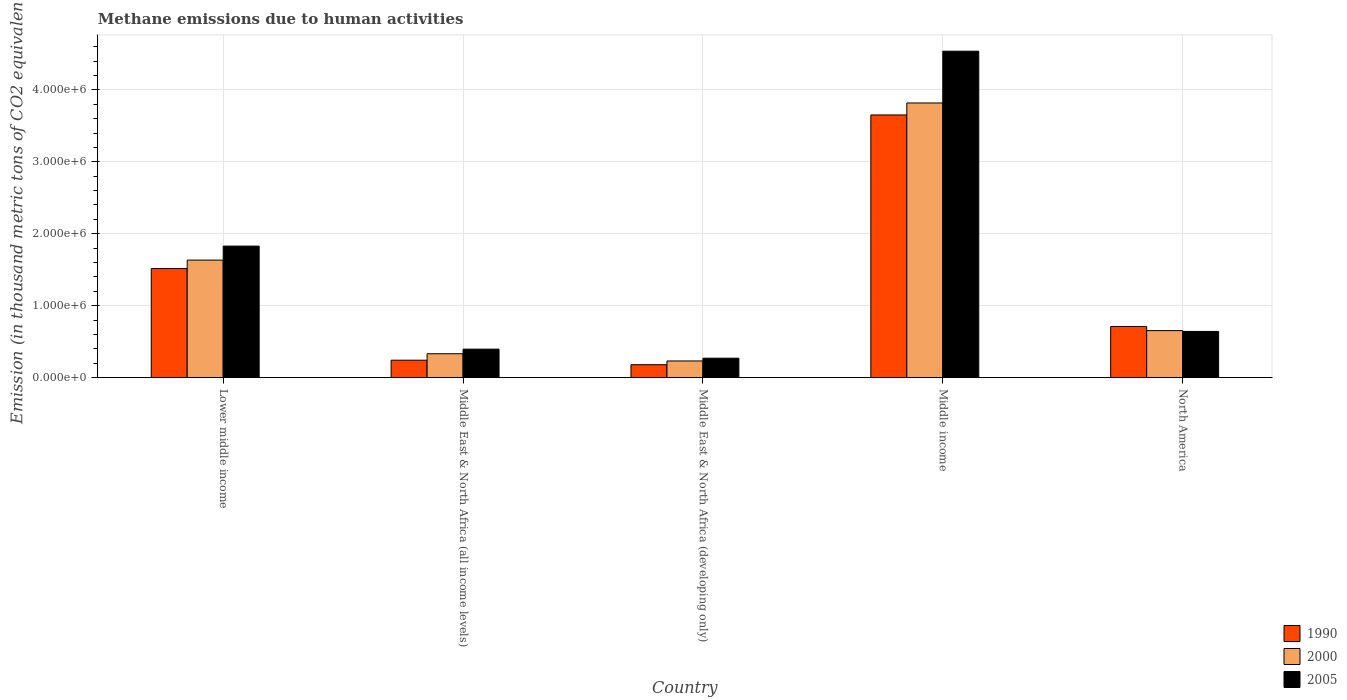How many bars are there on the 2nd tick from the left?
Give a very brief answer. 3. How many bars are there on the 3rd tick from the right?
Offer a very short reply. 3. What is the label of the 2nd group of bars from the left?
Your response must be concise. Middle East & North Africa (all income levels). In how many cases, is the number of bars for a given country not equal to the number of legend labels?
Your answer should be very brief. 0. What is the amount of methane emitted in 2005 in Middle income?
Make the answer very short. 4.54e+06. Across all countries, what is the maximum amount of methane emitted in 1990?
Your response must be concise. 3.65e+06. Across all countries, what is the minimum amount of methane emitted in 1990?
Provide a succinct answer. 1.80e+05. In which country was the amount of methane emitted in 2005 minimum?
Give a very brief answer. Middle East & North Africa (developing only). What is the total amount of methane emitted in 2000 in the graph?
Provide a succinct answer. 6.67e+06. What is the difference between the amount of methane emitted in 2005 in Middle East & North Africa (developing only) and that in Middle income?
Give a very brief answer. -4.27e+06. What is the difference between the amount of methane emitted in 1990 in North America and the amount of methane emitted in 2000 in Middle income?
Your answer should be compact. -3.11e+06. What is the average amount of methane emitted in 2005 per country?
Give a very brief answer. 1.54e+06. What is the difference between the amount of methane emitted of/in 1990 and amount of methane emitted of/in 2000 in Lower middle income?
Make the answer very short. -1.18e+05. In how many countries, is the amount of methane emitted in 2005 greater than 4400000 thousand metric tons?
Provide a short and direct response. 1. What is the ratio of the amount of methane emitted in 1990 in Middle East & North Africa (all income levels) to that in Middle income?
Your response must be concise. 0.07. Is the amount of methane emitted in 2000 in Middle East & North Africa (all income levels) less than that in Middle East & North Africa (developing only)?
Keep it short and to the point. No. What is the difference between the highest and the second highest amount of methane emitted in 1990?
Offer a very short reply. 2.94e+06. What is the difference between the highest and the lowest amount of methane emitted in 2005?
Your answer should be compact. 4.27e+06. In how many countries, is the amount of methane emitted in 2005 greater than the average amount of methane emitted in 2005 taken over all countries?
Provide a short and direct response. 2. Is it the case that in every country, the sum of the amount of methane emitted in 1990 and amount of methane emitted in 2000 is greater than the amount of methane emitted in 2005?
Make the answer very short. Yes. Are all the bars in the graph horizontal?
Offer a very short reply. No. Are the values on the major ticks of Y-axis written in scientific E-notation?
Your answer should be compact. Yes. Where does the legend appear in the graph?
Your answer should be compact. Bottom right. What is the title of the graph?
Ensure brevity in your answer.  Methane emissions due to human activities. What is the label or title of the Y-axis?
Your answer should be very brief. Emission (in thousand metric tons of CO2 equivalent). What is the Emission (in thousand metric tons of CO2 equivalent) in 1990 in Lower middle income?
Ensure brevity in your answer.  1.52e+06. What is the Emission (in thousand metric tons of CO2 equivalent) in 2000 in Lower middle income?
Your response must be concise. 1.63e+06. What is the Emission (in thousand metric tons of CO2 equivalent) in 2005 in Lower middle income?
Ensure brevity in your answer.  1.83e+06. What is the Emission (in thousand metric tons of CO2 equivalent) of 1990 in Middle East & North Africa (all income levels)?
Offer a very short reply. 2.43e+05. What is the Emission (in thousand metric tons of CO2 equivalent) in 2000 in Middle East & North Africa (all income levels)?
Offer a terse response. 3.33e+05. What is the Emission (in thousand metric tons of CO2 equivalent) of 2005 in Middle East & North Africa (all income levels)?
Offer a very short reply. 3.96e+05. What is the Emission (in thousand metric tons of CO2 equivalent) in 1990 in Middle East & North Africa (developing only)?
Offer a very short reply. 1.80e+05. What is the Emission (in thousand metric tons of CO2 equivalent) of 2000 in Middle East & North Africa (developing only)?
Your answer should be compact. 2.32e+05. What is the Emission (in thousand metric tons of CO2 equivalent) of 2005 in Middle East & North Africa (developing only)?
Offer a terse response. 2.71e+05. What is the Emission (in thousand metric tons of CO2 equivalent) in 1990 in Middle income?
Keep it short and to the point. 3.65e+06. What is the Emission (in thousand metric tons of CO2 equivalent) in 2000 in Middle income?
Give a very brief answer. 3.82e+06. What is the Emission (in thousand metric tons of CO2 equivalent) in 2005 in Middle income?
Your answer should be very brief. 4.54e+06. What is the Emission (in thousand metric tons of CO2 equivalent) of 1990 in North America?
Ensure brevity in your answer.  7.11e+05. What is the Emission (in thousand metric tons of CO2 equivalent) of 2000 in North America?
Your response must be concise. 6.54e+05. What is the Emission (in thousand metric tons of CO2 equivalent) in 2005 in North America?
Offer a very short reply. 6.42e+05. Across all countries, what is the maximum Emission (in thousand metric tons of CO2 equivalent) of 1990?
Provide a succinct answer. 3.65e+06. Across all countries, what is the maximum Emission (in thousand metric tons of CO2 equivalent) of 2000?
Give a very brief answer. 3.82e+06. Across all countries, what is the maximum Emission (in thousand metric tons of CO2 equivalent) in 2005?
Your answer should be very brief. 4.54e+06. Across all countries, what is the minimum Emission (in thousand metric tons of CO2 equivalent) of 1990?
Your answer should be very brief. 1.80e+05. Across all countries, what is the minimum Emission (in thousand metric tons of CO2 equivalent) of 2000?
Provide a short and direct response. 2.32e+05. Across all countries, what is the minimum Emission (in thousand metric tons of CO2 equivalent) in 2005?
Keep it short and to the point. 2.71e+05. What is the total Emission (in thousand metric tons of CO2 equivalent) of 1990 in the graph?
Your answer should be very brief. 6.30e+06. What is the total Emission (in thousand metric tons of CO2 equivalent) in 2000 in the graph?
Your answer should be compact. 6.67e+06. What is the total Emission (in thousand metric tons of CO2 equivalent) of 2005 in the graph?
Give a very brief answer. 7.68e+06. What is the difference between the Emission (in thousand metric tons of CO2 equivalent) of 1990 in Lower middle income and that in Middle East & North Africa (all income levels)?
Make the answer very short. 1.27e+06. What is the difference between the Emission (in thousand metric tons of CO2 equivalent) of 2000 in Lower middle income and that in Middle East & North Africa (all income levels)?
Your response must be concise. 1.30e+06. What is the difference between the Emission (in thousand metric tons of CO2 equivalent) in 2005 in Lower middle income and that in Middle East & North Africa (all income levels)?
Ensure brevity in your answer.  1.43e+06. What is the difference between the Emission (in thousand metric tons of CO2 equivalent) in 1990 in Lower middle income and that in Middle East & North Africa (developing only)?
Your response must be concise. 1.34e+06. What is the difference between the Emission (in thousand metric tons of CO2 equivalent) of 2000 in Lower middle income and that in Middle East & North Africa (developing only)?
Give a very brief answer. 1.40e+06. What is the difference between the Emission (in thousand metric tons of CO2 equivalent) in 2005 in Lower middle income and that in Middle East & North Africa (developing only)?
Your response must be concise. 1.56e+06. What is the difference between the Emission (in thousand metric tons of CO2 equivalent) in 1990 in Lower middle income and that in Middle income?
Make the answer very short. -2.13e+06. What is the difference between the Emission (in thousand metric tons of CO2 equivalent) in 2000 in Lower middle income and that in Middle income?
Your answer should be very brief. -2.18e+06. What is the difference between the Emission (in thousand metric tons of CO2 equivalent) of 2005 in Lower middle income and that in Middle income?
Your answer should be very brief. -2.71e+06. What is the difference between the Emission (in thousand metric tons of CO2 equivalent) in 1990 in Lower middle income and that in North America?
Ensure brevity in your answer.  8.05e+05. What is the difference between the Emission (in thousand metric tons of CO2 equivalent) of 2000 in Lower middle income and that in North America?
Your response must be concise. 9.80e+05. What is the difference between the Emission (in thousand metric tons of CO2 equivalent) in 2005 in Lower middle income and that in North America?
Provide a succinct answer. 1.19e+06. What is the difference between the Emission (in thousand metric tons of CO2 equivalent) of 1990 in Middle East & North Africa (all income levels) and that in Middle East & North Africa (developing only)?
Your answer should be very brief. 6.28e+04. What is the difference between the Emission (in thousand metric tons of CO2 equivalent) in 2000 in Middle East & North Africa (all income levels) and that in Middle East & North Africa (developing only)?
Make the answer very short. 1.01e+05. What is the difference between the Emission (in thousand metric tons of CO2 equivalent) of 2005 in Middle East & North Africa (all income levels) and that in Middle East & North Africa (developing only)?
Offer a terse response. 1.26e+05. What is the difference between the Emission (in thousand metric tons of CO2 equivalent) in 1990 in Middle East & North Africa (all income levels) and that in Middle income?
Ensure brevity in your answer.  -3.41e+06. What is the difference between the Emission (in thousand metric tons of CO2 equivalent) of 2000 in Middle East & North Africa (all income levels) and that in Middle income?
Your answer should be compact. -3.49e+06. What is the difference between the Emission (in thousand metric tons of CO2 equivalent) in 2005 in Middle East & North Africa (all income levels) and that in Middle income?
Offer a very short reply. -4.14e+06. What is the difference between the Emission (in thousand metric tons of CO2 equivalent) of 1990 in Middle East & North Africa (all income levels) and that in North America?
Offer a terse response. -4.68e+05. What is the difference between the Emission (in thousand metric tons of CO2 equivalent) in 2000 in Middle East & North Africa (all income levels) and that in North America?
Your response must be concise. -3.21e+05. What is the difference between the Emission (in thousand metric tons of CO2 equivalent) of 2005 in Middle East & North Africa (all income levels) and that in North America?
Offer a very short reply. -2.46e+05. What is the difference between the Emission (in thousand metric tons of CO2 equivalent) of 1990 in Middle East & North Africa (developing only) and that in Middle income?
Provide a succinct answer. -3.47e+06. What is the difference between the Emission (in thousand metric tons of CO2 equivalent) in 2000 in Middle East & North Africa (developing only) and that in Middle income?
Give a very brief answer. -3.59e+06. What is the difference between the Emission (in thousand metric tons of CO2 equivalent) in 2005 in Middle East & North Africa (developing only) and that in Middle income?
Offer a terse response. -4.27e+06. What is the difference between the Emission (in thousand metric tons of CO2 equivalent) of 1990 in Middle East & North Africa (developing only) and that in North America?
Your answer should be very brief. -5.31e+05. What is the difference between the Emission (in thousand metric tons of CO2 equivalent) of 2000 in Middle East & North Africa (developing only) and that in North America?
Your response must be concise. -4.22e+05. What is the difference between the Emission (in thousand metric tons of CO2 equivalent) in 2005 in Middle East & North Africa (developing only) and that in North America?
Offer a very short reply. -3.72e+05. What is the difference between the Emission (in thousand metric tons of CO2 equivalent) in 1990 in Middle income and that in North America?
Your answer should be very brief. 2.94e+06. What is the difference between the Emission (in thousand metric tons of CO2 equivalent) in 2000 in Middle income and that in North America?
Offer a very short reply. 3.16e+06. What is the difference between the Emission (in thousand metric tons of CO2 equivalent) of 2005 in Middle income and that in North America?
Keep it short and to the point. 3.89e+06. What is the difference between the Emission (in thousand metric tons of CO2 equivalent) of 1990 in Lower middle income and the Emission (in thousand metric tons of CO2 equivalent) of 2000 in Middle East & North Africa (all income levels)?
Offer a terse response. 1.18e+06. What is the difference between the Emission (in thousand metric tons of CO2 equivalent) in 1990 in Lower middle income and the Emission (in thousand metric tons of CO2 equivalent) in 2005 in Middle East & North Africa (all income levels)?
Your answer should be compact. 1.12e+06. What is the difference between the Emission (in thousand metric tons of CO2 equivalent) of 2000 in Lower middle income and the Emission (in thousand metric tons of CO2 equivalent) of 2005 in Middle East & North Africa (all income levels)?
Keep it short and to the point. 1.24e+06. What is the difference between the Emission (in thousand metric tons of CO2 equivalent) in 1990 in Lower middle income and the Emission (in thousand metric tons of CO2 equivalent) in 2000 in Middle East & North Africa (developing only)?
Your response must be concise. 1.28e+06. What is the difference between the Emission (in thousand metric tons of CO2 equivalent) of 1990 in Lower middle income and the Emission (in thousand metric tons of CO2 equivalent) of 2005 in Middle East & North Africa (developing only)?
Your response must be concise. 1.25e+06. What is the difference between the Emission (in thousand metric tons of CO2 equivalent) of 2000 in Lower middle income and the Emission (in thousand metric tons of CO2 equivalent) of 2005 in Middle East & North Africa (developing only)?
Your response must be concise. 1.36e+06. What is the difference between the Emission (in thousand metric tons of CO2 equivalent) in 1990 in Lower middle income and the Emission (in thousand metric tons of CO2 equivalent) in 2000 in Middle income?
Keep it short and to the point. -2.30e+06. What is the difference between the Emission (in thousand metric tons of CO2 equivalent) in 1990 in Lower middle income and the Emission (in thousand metric tons of CO2 equivalent) in 2005 in Middle income?
Offer a very short reply. -3.02e+06. What is the difference between the Emission (in thousand metric tons of CO2 equivalent) in 2000 in Lower middle income and the Emission (in thousand metric tons of CO2 equivalent) in 2005 in Middle income?
Ensure brevity in your answer.  -2.90e+06. What is the difference between the Emission (in thousand metric tons of CO2 equivalent) in 1990 in Lower middle income and the Emission (in thousand metric tons of CO2 equivalent) in 2000 in North America?
Your answer should be compact. 8.62e+05. What is the difference between the Emission (in thousand metric tons of CO2 equivalent) in 1990 in Lower middle income and the Emission (in thousand metric tons of CO2 equivalent) in 2005 in North America?
Make the answer very short. 8.74e+05. What is the difference between the Emission (in thousand metric tons of CO2 equivalent) of 2000 in Lower middle income and the Emission (in thousand metric tons of CO2 equivalent) of 2005 in North America?
Your answer should be very brief. 9.92e+05. What is the difference between the Emission (in thousand metric tons of CO2 equivalent) of 1990 in Middle East & North Africa (all income levels) and the Emission (in thousand metric tons of CO2 equivalent) of 2000 in Middle East & North Africa (developing only)?
Your answer should be compact. 1.08e+04. What is the difference between the Emission (in thousand metric tons of CO2 equivalent) of 1990 in Middle East & North Africa (all income levels) and the Emission (in thousand metric tons of CO2 equivalent) of 2005 in Middle East & North Africa (developing only)?
Give a very brief answer. -2.77e+04. What is the difference between the Emission (in thousand metric tons of CO2 equivalent) of 2000 in Middle East & North Africa (all income levels) and the Emission (in thousand metric tons of CO2 equivalent) of 2005 in Middle East & North Africa (developing only)?
Keep it short and to the point. 6.22e+04. What is the difference between the Emission (in thousand metric tons of CO2 equivalent) in 1990 in Middle East & North Africa (all income levels) and the Emission (in thousand metric tons of CO2 equivalent) in 2000 in Middle income?
Ensure brevity in your answer.  -3.57e+06. What is the difference between the Emission (in thousand metric tons of CO2 equivalent) of 1990 in Middle East & North Africa (all income levels) and the Emission (in thousand metric tons of CO2 equivalent) of 2005 in Middle income?
Offer a very short reply. -4.29e+06. What is the difference between the Emission (in thousand metric tons of CO2 equivalent) of 2000 in Middle East & North Africa (all income levels) and the Emission (in thousand metric tons of CO2 equivalent) of 2005 in Middle income?
Offer a terse response. -4.20e+06. What is the difference between the Emission (in thousand metric tons of CO2 equivalent) in 1990 in Middle East & North Africa (all income levels) and the Emission (in thousand metric tons of CO2 equivalent) in 2000 in North America?
Provide a short and direct response. -4.11e+05. What is the difference between the Emission (in thousand metric tons of CO2 equivalent) of 1990 in Middle East & North Africa (all income levels) and the Emission (in thousand metric tons of CO2 equivalent) of 2005 in North America?
Your answer should be very brief. -4.00e+05. What is the difference between the Emission (in thousand metric tons of CO2 equivalent) in 2000 in Middle East & North Africa (all income levels) and the Emission (in thousand metric tons of CO2 equivalent) in 2005 in North America?
Your answer should be very brief. -3.10e+05. What is the difference between the Emission (in thousand metric tons of CO2 equivalent) of 1990 in Middle East & North Africa (developing only) and the Emission (in thousand metric tons of CO2 equivalent) of 2000 in Middle income?
Give a very brief answer. -3.64e+06. What is the difference between the Emission (in thousand metric tons of CO2 equivalent) of 1990 in Middle East & North Africa (developing only) and the Emission (in thousand metric tons of CO2 equivalent) of 2005 in Middle income?
Provide a succinct answer. -4.36e+06. What is the difference between the Emission (in thousand metric tons of CO2 equivalent) in 2000 in Middle East & North Africa (developing only) and the Emission (in thousand metric tons of CO2 equivalent) in 2005 in Middle income?
Your answer should be very brief. -4.31e+06. What is the difference between the Emission (in thousand metric tons of CO2 equivalent) of 1990 in Middle East & North Africa (developing only) and the Emission (in thousand metric tons of CO2 equivalent) of 2000 in North America?
Your answer should be compact. -4.74e+05. What is the difference between the Emission (in thousand metric tons of CO2 equivalent) of 1990 in Middle East & North Africa (developing only) and the Emission (in thousand metric tons of CO2 equivalent) of 2005 in North America?
Make the answer very short. -4.62e+05. What is the difference between the Emission (in thousand metric tons of CO2 equivalent) of 2000 in Middle East & North Africa (developing only) and the Emission (in thousand metric tons of CO2 equivalent) of 2005 in North America?
Ensure brevity in your answer.  -4.10e+05. What is the difference between the Emission (in thousand metric tons of CO2 equivalent) in 1990 in Middle income and the Emission (in thousand metric tons of CO2 equivalent) in 2000 in North America?
Provide a short and direct response. 3.00e+06. What is the difference between the Emission (in thousand metric tons of CO2 equivalent) of 1990 in Middle income and the Emission (in thousand metric tons of CO2 equivalent) of 2005 in North America?
Your response must be concise. 3.01e+06. What is the difference between the Emission (in thousand metric tons of CO2 equivalent) of 2000 in Middle income and the Emission (in thousand metric tons of CO2 equivalent) of 2005 in North America?
Your response must be concise. 3.18e+06. What is the average Emission (in thousand metric tons of CO2 equivalent) in 1990 per country?
Give a very brief answer. 1.26e+06. What is the average Emission (in thousand metric tons of CO2 equivalent) of 2000 per country?
Your answer should be very brief. 1.33e+06. What is the average Emission (in thousand metric tons of CO2 equivalent) in 2005 per country?
Offer a terse response. 1.54e+06. What is the difference between the Emission (in thousand metric tons of CO2 equivalent) of 1990 and Emission (in thousand metric tons of CO2 equivalent) of 2000 in Lower middle income?
Keep it short and to the point. -1.18e+05. What is the difference between the Emission (in thousand metric tons of CO2 equivalent) in 1990 and Emission (in thousand metric tons of CO2 equivalent) in 2005 in Lower middle income?
Your response must be concise. -3.12e+05. What is the difference between the Emission (in thousand metric tons of CO2 equivalent) of 2000 and Emission (in thousand metric tons of CO2 equivalent) of 2005 in Lower middle income?
Your answer should be compact. -1.94e+05. What is the difference between the Emission (in thousand metric tons of CO2 equivalent) in 1990 and Emission (in thousand metric tons of CO2 equivalent) in 2000 in Middle East & North Africa (all income levels)?
Offer a terse response. -8.99e+04. What is the difference between the Emission (in thousand metric tons of CO2 equivalent) in 1990 and Emission (in thousand metric tons of CO2 equivalent) in 2005 in Middle East & North Africa (all income levels)?
Give a very brief answer. -1.54e+05. What is the difference between the Emission (in thousand metric tons of CO2 equivalent) in 2000 and Emission (in thousand metric tons of CO2 equivalent) in 2005 in Middle East & North Africa (all income levels)?
Give a very brief answer. -6.37e+04. What is the difference between the Emission (in thousand metric tons of CO2 equivalent) of 1990 and Emission (in thousand metric tons of CO2 equivalent) of 2000 in Middle East & North Africa (developing only)?
Keep it short and to the point. -5.20e+04. What is the difference between the Emission (in thousand metric tons of CO2 equivalent) of 1990 and Emission (in thousand metric tons of CO2 equivalent) of 2005 in Middle East & North Africa (developing only)?
Keep it short and to the point. -9.05e+04. What is the difference between the Emission (in thousand metric tons of CO2 equivalent) in 2000 and Emission (in thousand metric tons of CO2 equivalent) in 2005 in Middle East & North Africa (developing only)?
Offer a very short reply. -3.84e+04. What is the difference between the Emission (in thousand metric tons of CO2 equivalent) of 1990 and Emission (in thousand metric tons of CO2 equivalent) of 2000 in Middle income?
Your response must be concise. -1.67e+05. What is the difference between the Emission (in thousand metric tons of CO2 equivalent) of 1990 and Emission (in thousand metric tons of CO2 equivalent) of 2005 in Middle income?
Your response must be concise. -8.86e+05. What is the difference between the Emission (in thousand metric tons of CO2 equivalent) of 2000 and Emission (in thousand metric tons of CO2 equivalent) of 2005 in Middle income?
Your answer should be very brief. -7.20e+05. What is the difference between the Emission (in thousand metric tons of CO2 equivalent) in 1990 and Emission (in thousand metric tons of CO2 equivalent) in 2000 in North America?
Provide a short and direct response. 5.71e+04. What is the difference between the Emission (in thousand metric tons of CO2 equivalent) of 1990 and Emission (in thousand metric tons of CO2 equivalent) of 2005 in North America?
Offer a terse response. 6.87e+04. What is the difference between the Emission (in thousand metric tons of CO2 equivalent) in 2000 and Emission (in thousand metric tons of CO2 equivalent) in 2005 in North America?
Your answer should be compact. 1.17e+04. What is the ratio of the Emission (in thousand metric tons of CO2 equivalent) in 1990 in Lower middle income to that in Middle East & North Africa (all income levels)?
Keep it short and to the point. 6.24. What is the ratio of the Emission (in thousand metric tons of CO2 equivalent) in 2000 in Lower middle income to that in Middle East & North Africa (all income levels)?
Your answer should be very brief. 4.91. What is the ratio of the Emission (in thousand metric tons of CO2 equivalent) of 2005 in Lower middle income to that in Middle East & North Africa (all income levels)?
Keep it short and to the point. 4.61. What is the ratio of the Emission (in thousand metric tons of CO2 equivalent) in 1990 in Lower middle income to that in Middle East & North Africa (developing only)?
Make the answer very short. 8.42. What is the ratio of the Emission (in thousand metric tons of CO2 equivalent) in 2000 in Lower middle income to that in Middle East & North Africa (developing only)?
Offer a terse response. 7.04. What is the ratio of the Emission (in thousand metric tons of CO2 equivalent) of 2005 in Lower middle income to that in Middle East & North Africa (developing only)?
Offer a terse response. 6.76. What is the ratio of the Emission (in thousand metric tons of CO2 equivalent) in 1990 in Lower middle income to that in Middle income?
Provide a short and direct response. 0.42. What is the ratio of the Emission (in thousand metric tons of CO2 equivalent) of 2000 in Lower middle income to that in Middle income?
Offer a terse response. 0.43. What is the ratio of the Emission (in thousand metric tons of CO2 equivalent) of 2005 in Lower middle income to that in Middle income?
Provide a succinct answer. 0.4. What is the ratio of the Emission (in thousand metric tons of CO2 equivalent) in 1990 in Lower middle income to that in North America?
Offer a very short reply. 2.13. What is the ratio of the Emission (in thousand metric tons of CO2 equivalent) in 2000 in Lower middle income to that in North America?
Keep it short and to the point. 2.5. What is the ratio of the Emission (in thousand metric tons of CO2 equivalent) in 2005 in Lower middle income to that in North America?
Your response must be concise. 2.85. What is the ratio of the Emission (in thousand metric tons of CO2 equivalent) of 1990 in Middle East & North Africa (all income levels) to that in Middle East & North Africa (developing only)?
Provide a short and direct response. 1.35. What is the ratio of the Emission (in thousand metric tons of CO2 equivalent) of 2000 in Middle East & North Africa (all income levels) to that in Middle East & North Africa (developing only)?
Give a very brief answer. 1.43. What is the ratio of the Emission (in thousand metric tons of CO2 equivalent) in 2005 in Middle East & North Africa (all income levels) to that in Middle East & North Africa (developing only)?
Your response must be concise. 1.47. What is the ratio of the Emission (in thousand metric tons of CO2 equivalent) in 1990 in Middle East & North Africa (all income levels) to that in Middle income?
Ensure brevity in your answer.  0.07. What is the ratio of the Emission (in thousand metric tons of CO2 equivalent) in 2000 in Middle East & North Africa (all income levels) to that in Middle income?
Offer a very short reply. 0.09. What is the ratio of the Emission (in thousand metric tons of CO2 equivalent) of 2005 in Middle East & North Africa (all income levels) to that in Middle income?
Offer a terse response. 0.09. What is the ratio of the Emission (in thousand metric tons of CO2 equivalent) of 1990 in Middle East & North Africa (all income levels) to that in North America?
Ensure brevity in your answer.  0.34. What is the ratio of the Emission (in thousand metric tons of CO2 equivalent) of 2000 in Middle East & North Africa (all income levels) to that in North America?
Your answer should be very brief. 0.51. What is the ratio of the Emission (in thousand metric tons of CO2 equivalent) in 2005 in Middle East & North Africa (all income levels) to that in North America?
Your answer should be very brief. 0.62. What is the ratio of the Emission (in thousand metric tons of CO2 equivalent) of 1990 in Middle East & North Africa (developing only) to that in Middle income?
Give a very brief answer. 0.05. What is the ratio of the Emission (in thousand metric tons of CO2 equivalent) in 2000 in Middle East & North Africa (developing only) to that in Middle income?
Provide a succinct answer. 0.06. What is the ratio of the Emission (in thousand metric tons of CO2 equivalent) in 2005 in Middle East & North Africa (developing only) to that in Middle income?
Your response must be concise. 0.06. What is the ratio of the Emission (in thousand metric tons of CO2 equivalent) of 1990 in Middle East & North Africa (developing only) to that in North America?
Your answer should be very brief. 0.25. What is the ratio of the Emission (in thousand metric tons of CO2 equivalent) of 2000 in Middle East & North Africa (developing only) to that in North America?
Offer a very short reply. 0.35. What is the ratio of the Emission (in thousand metric tons of CO2 equivalent) in 2005 in Middle East & North Africa (developing only) to that in North America?
Your response must be concise. 0.42. What is the ratio of the Emission (in thousand metric tons of CO2 equivalent) of 1990 in Middle income to that in North America?
Offer a terse response. 5.13. What is the ratio of the Emission (in thousand metric tons of CO2 equivalent) of 2000 in Middle income to that in North America?
Provide a short and direct response. 5.84. What is the ratio of the Emission (in thousand metric tons of CO2 equivalent) of 2005 in Middle income to that in North America?
Offer a very short reply. 7.06. What is the difference between the highest and the second highest Emission (in thousand metric tons of CO2 equivalent) in 1990?
Provide a succinct answer. 2.13e+06. What is the difference between the highest and the second highest Emission (in thousand metric tons of CO2 equivalent) in 2000?
Give a very brief answer. 2.18e+06. What is the difference between the highest and the second highest Emission (in thousand metric tons of CO2 equivalent) of 2005?
Keep it short and to the point. 2.71e+06. What is the difference between the highest and the lowest Emission (in thousand metric tons of CO2 equivalent) of 1990?
Your answer should be very brief. 3.47e+06. What is the difference between the highest and the lowest Emission (in thousand metric tons of CO2 equivalent) of 2000?
Offer a very short reply. 3.59e+06. What is the difference between the highest and the lowest Emission (in thousand metric tons of CO2 equivalent) in 2005?
Provide a short and direct response. 4.27e+06. 